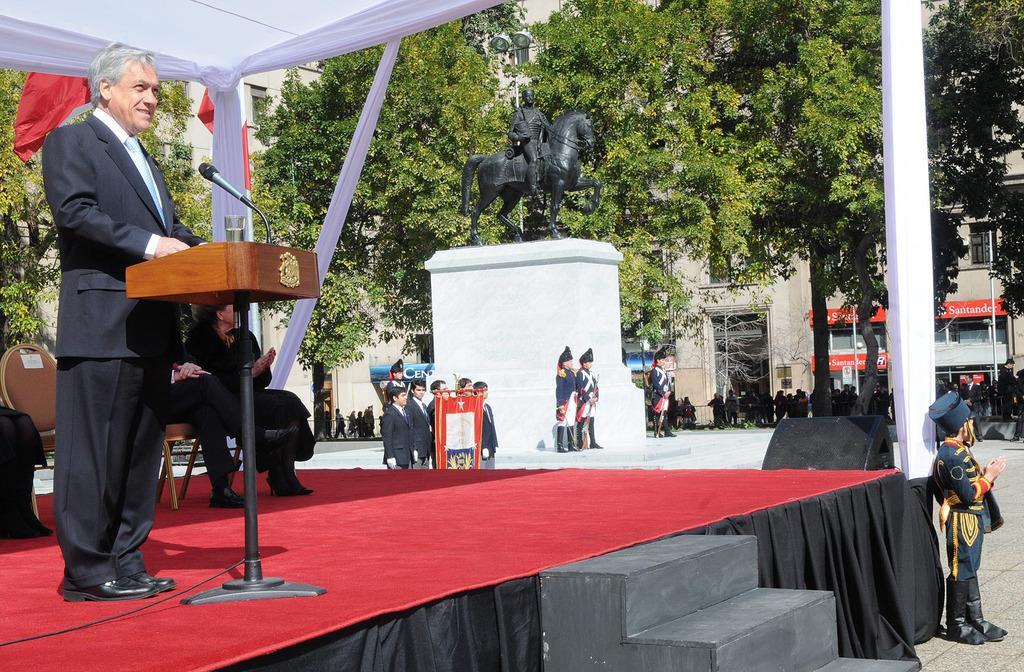Could you give a brief overview of what you see in this image? In this image I can see few people are on the stage. I can see one person standing in-front of the podium and on the podium I can see the mic and the glass. To the right I can see many people, statue of the person sitting on the horse, many trees and the buildings with the windows and the boards. 